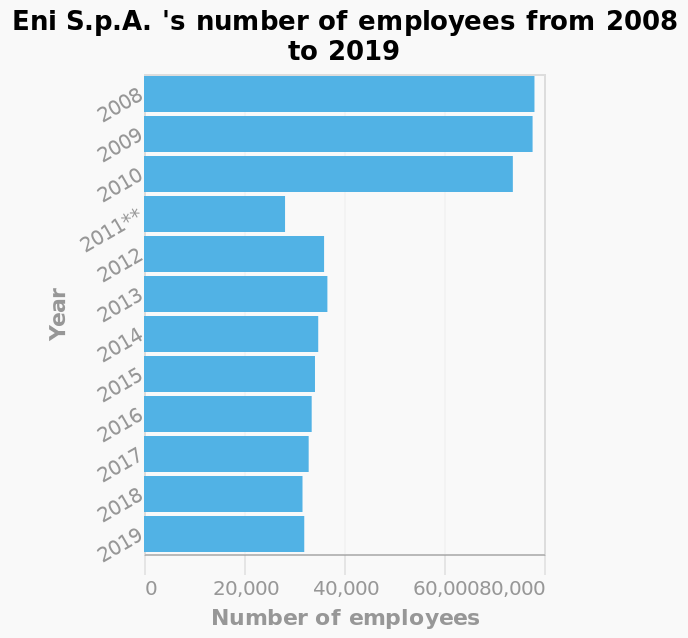<image>
Has there been a continuous decrease in the number of employees throughout the period shown in the bar chart?  Yes, there has been a continuous decrease in the number of employees from 2008 to 2019. Offer a thorough analysis of the image. Eni S.p.A. 's number of employees was close to 80,000 for a number of years, before they reduced the number by over a half in 2011, by which they have since maintained under 40,000 employees. How many employees did Eni S.p.A. have in the year 2015?  The number of employees at Eni S.p.A. in the year 2015 is not provided in the description. please enumerates aspects of the construction of the chart Eni S.p.A. 's number of employees from 2008 to 2019 is a bar chart. There is a linear scale with a minimum of 2008 and a maximum of 2019 along the y-axis, marked Year. Along the x-axis, Number of employees is measured with a linear scale from 0 to 80,000. What was the highest number of employees recorded for Eni S.p.A. during the given time period?  The description does not specify the highest number of employees recorded for Eni S.p.A. during the given time period. When did the biggest decrease in the number of employees occur?  The biggest decrease in the number of employees happened after 2010. please summary the statistics and relations of the chart I can see from the bar chart there has been a drastic reduction in the number of employees from 2008 t0 2019, the biggest decrease happened after 2010. Did the biggest increase in the number of employees happen after 2010? No. The biggest decrease in the number of employees happened after 2010. 